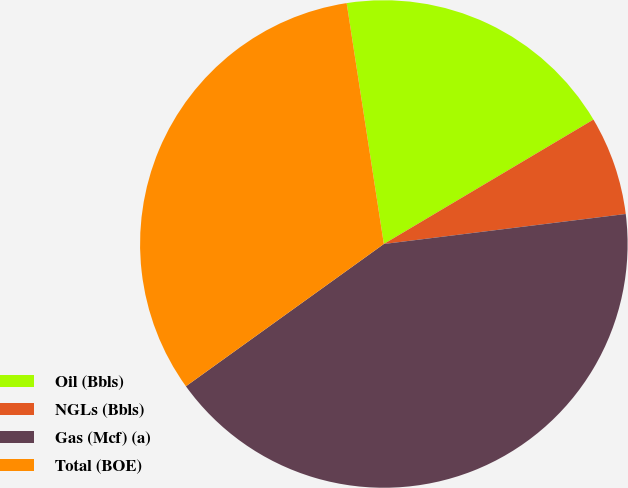Convert chart to OTSL. <chart><loc_0><loc_0><loc_500><loc_500><pie_chart><fcel>Oil (Bbls)<fcel>NGLs (Bbls)<fcel>Gas (Mcf) (a)<fcel>Total (BOE)<nl><fcel>18.91%<fcel>6.56%<fcel>42.04%<fcel>32.48%<nl></chart> 